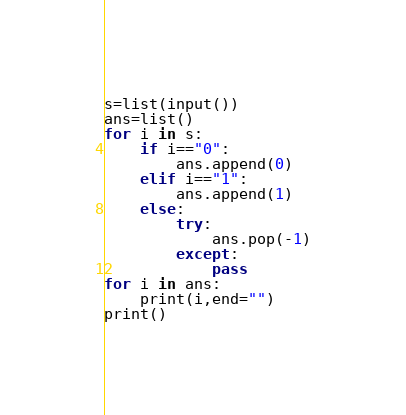Convert code to text. <code><loc_0><loc_0><loc_500><loc_500><_Python_>s=list(input())
ans=list()
for i in s:
    if i=="0":
        ans.append(0)
    elif i=="1":
        ans.append(1)
    else:
        try:
            ans.pop(-1)
        except:
            pass
for i in ans:
    print(i,end="")
print()</code> 